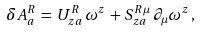<formula> <loc_0><loc_0><loc_500><loc_500>\delta A _ { a } ^ { R } \, = \, U ^ { R } _ { z a } \, \omega ^ { z } \, + \, S ^ { R \mu } _ { z a } \, \partial _ { \mu } \omega ^ { z } \, ,</formula> 